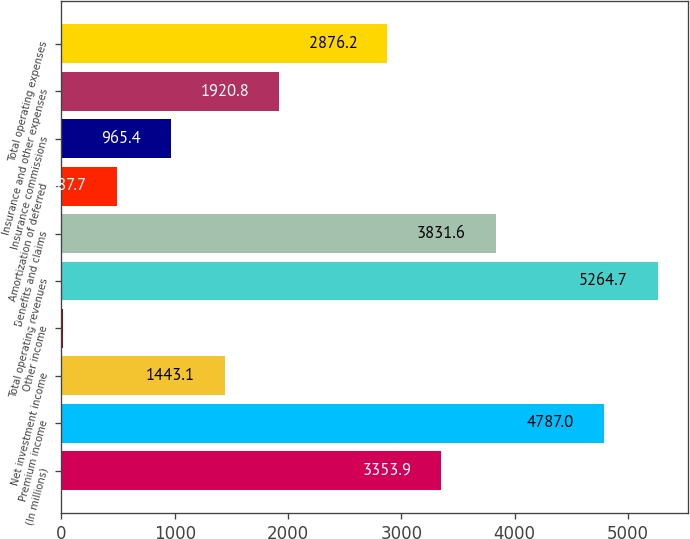<chart> <loc_0><loc_0><loc_500><loc_500><bar_chart><fcel>(In millions)<fcel>Premium income<fcel>Net investment income<fcel>Other income<fcel>Total operating revenues<fcel>Benefits and claims<fcel>Amortization of deferred<fcel>Insurance commissions<fcel>Insurance and other expenses<fcel>Total operating expenses<nl><fcel>3353.9<fcel>4787<fcel>1443.1<fcel>10<fcel>5264.7<fcel>3831.6<fcel>487.7<fcel>965.4<fcel>1920.8<fcel>2876.2<nl></chart> 